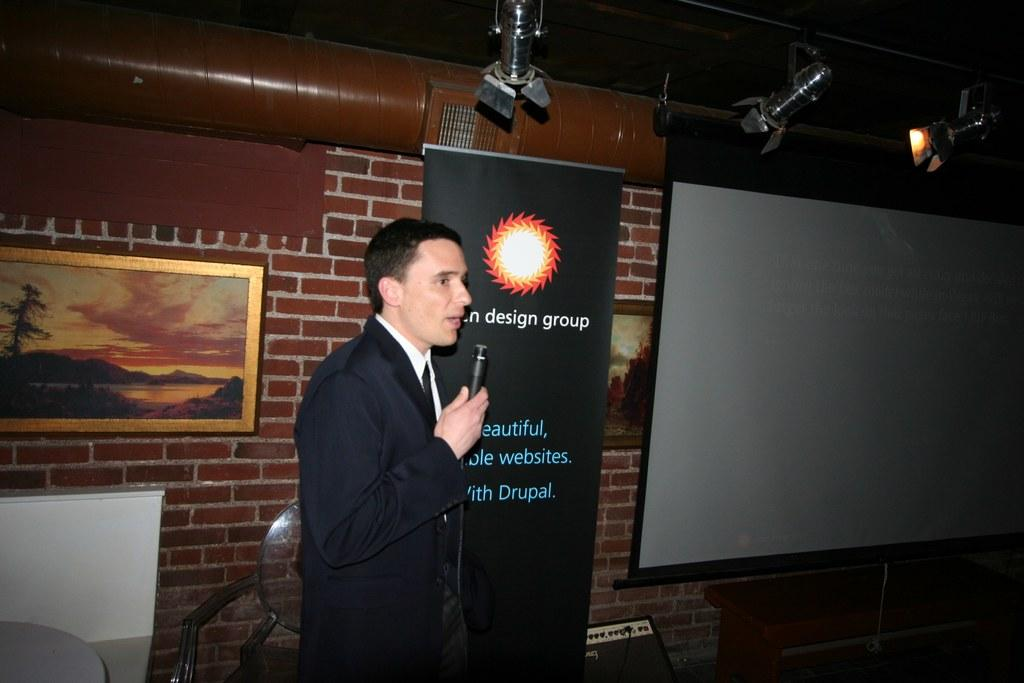What is the main subject of the image? There is a person in the image. What is the person wearing? The person is wearing a black jacket. What is the person holding? The person is holding a microphone. What type of background can be seen in the image? There is a brick wall in the image. What can be seen illuminating the scene? There are lights in the image. What other objects are present in the image? There is a photo frame and a screen in the image. What type of growth can be seen on the person's jacket in the image? There is no growth visible on the person's jacket in the image. What type of silk material is present in the image? There is no silk material present in the image. 